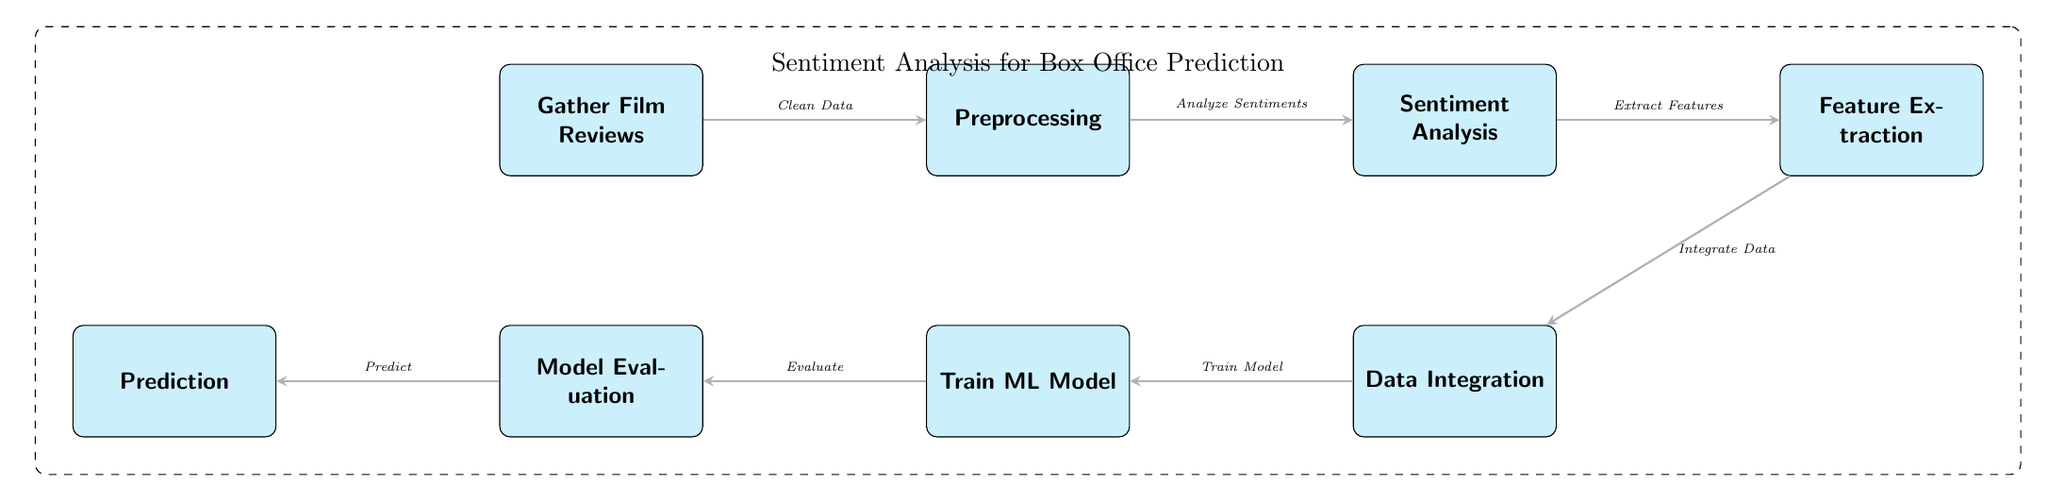What is the first step in the diagram? The first step in the diagram is represented by the node labeled "Gather Film Reviews".
Answer: Gather Film Reviews How many nodes are in the diagram? By counting the labeled nodes in the diagram, we see there are eight distinct nodes.
Answer: Eight What is the output of the "Train ML Model" step? The output of this step is indicated by the edge leading to the next node, labeled "Evaluate", suggesting model training results in evaluation.
Answer: Evaluate Which process follows after "Sentiment Analysis"? "Feature Extraction" follows directly after "Sentiment Analysis" as shown in the flow of the diagram.
Answer: Feature Extraction What is the relationship between "Preprocessing" and "Sentiment Analysis"? "Preprocessing" is performed before "Sentiment Analysis", indicating that preprocessing prepares the data for subsequent sentiment analysis.
Answer: Analyze Sentiments What type of diagram is this? This diagram is specifically a "Machine Learning Diagram" that illustrates the process of sentiment analysis for film review prediction.
Answer: Machine Learning Diagram What is the final output in the flow of this diagram? The final output is represented at the end node labeled "Prediction", which signifies the end goal of the process.
Answer: Prediction What action is taken after "Model Evaluation"? After "Model Evaluation", the next action is "Prediction", indicating that the evaluation informs the predicted outcome.
Answer: Predict What is the label of the dashed box surrounding the diagram? The dashed box is labeled "Sentiment Analysis for Box Office Prediction", which encapsulates the main focus of the diagram.
Answer: Sentiment Analysis for Box Office Prediction 